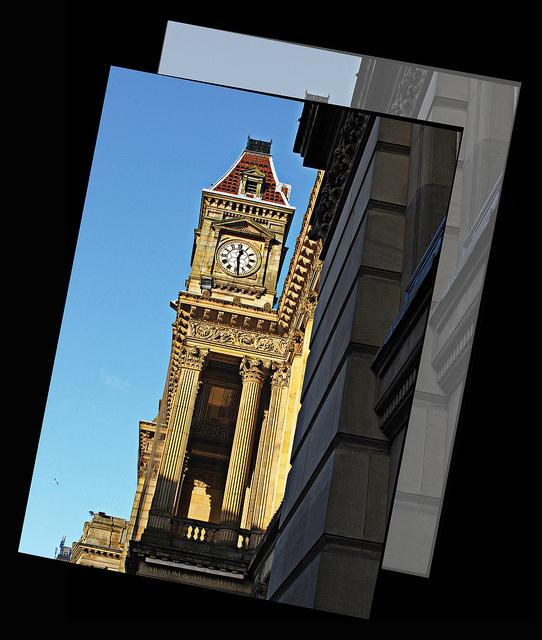How far off the ground is the clock?
Quick response, please. 30 feet. What time is on the clock?
Quick response, please. 12:30. Could the time be 5:06 PM?
Short answer required. No. What color is the building?
Concise answer only. Yellow. Is the picture tilted clockwise or counterclockwise?
Be succinct. Clockwise. What time was it on this picture?
Concise answer only. 12:30. Is there more than 1 picture?
Write a very short answer. Yes. Is it AM or PM?
Be succinct. Am. 